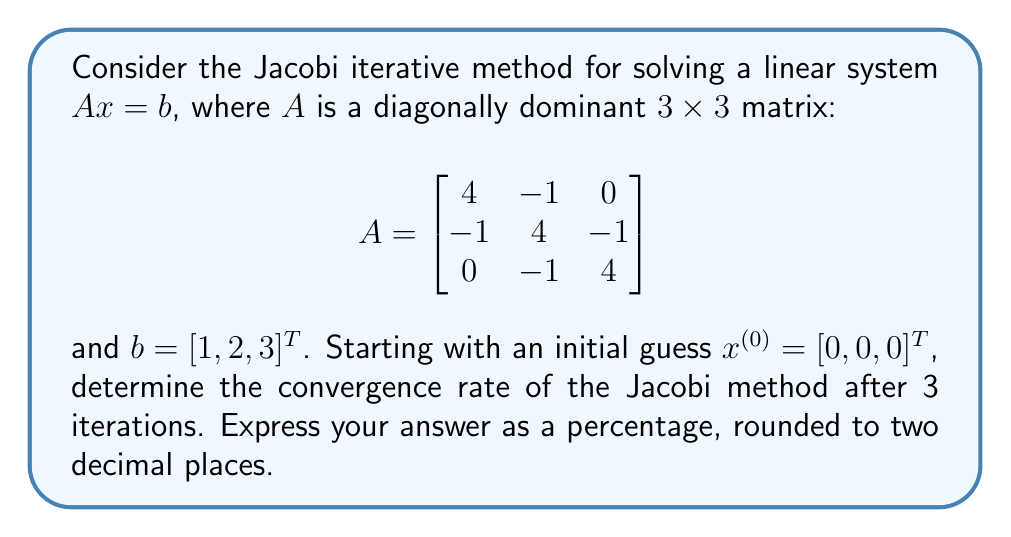Teach me how to tackle this problem. To analyze the convergence rate of the Jacobi method, we'll follow these steps:

1) First, we need to understand the Jacobi iteration formula:
   $x^{(k+1)} = D^{-1}(b - Rx^{(k)})$
   where $D$ is the diagonal of $A$, and $R = A - D$.

2) For our matrix $A$:
   $D = \begin{bmatrix}
   4 & 0 & 0 \\
   0 & 4 & 0 \\
   0 & 0 & 4
   \end{bmatrix}$
   
   $R = \begin{bmatrix}
   0 & -1 & 0 \\
   -1 & 0 & -1 \\
   0 & -1 & 0
   \end{bmatrix}$

3) The iteration formula becomes:
   $x_i^{(k+1)} = \frac{1}{4}(b_i - \sum_{j \neq i} a_{ij}x_j^{(k)})$

4) Let's perform 3 iterations:

   Iteration 1:
   $x_1^{(1)} = \frac{1}{4}(1 - 0) = 0.25$
   $x_2^{(1)} = \frac{1}{4}(2 - 0) = 0.5$
   $x_3^{(1)} = \frac{1}{4}(3 - 0) = 0.75$

   Iteration 2:
   $x_1^{(2)} = \frac{1}{4}(1 - (-0.5)) = 0.375$
   $x_2^{(2)} = \frac{1}{4}(2 - (-0.25 - 0.75)) = 0.75$
   $x_3^{(2)} = \frac{1}{4}(3 - (-0.5)) = 0.875$

   Iteration 3:
   $x_1^{(3)} = \frac{1}{4}(1 - (-0.75)) = 0.4375$
   $x_2^{(3)} = \frac{1}{4}(2 - (-0.375 - 0.875)) = 0.8125$
   $x_3^{(3)} = \frac{1}{4}(3 - (-0.75)) = 0.9375$

5) To calculate the convergence rate, we'll use the formula:
   Convergence Rate = $\left(1 - \frac{\|x^{(k)} - x^{(k-1)}\|}{\|x^{(k-1)} - x^{(k-2)}\|}\right) \times 100\%$

   where $\|\cdot\|$ denotes the Euclidean norm.

6) Calculate the norms:
   $\|x^{(3)} - x^{(2)}\| = \sqrt{(0.4375-0.375)^2 + (0.8125-0.75)^2 + (0.9375-0.875)^2} \approx 0.1083$
   $\|x^{(2)} - x^{(1)}\| = \sqrt{(0.375-0.25)^2 + (0.75-0.5)^2 + (0.875-0.75)^2} \approx 0.3307$

7) Apply the convergence rate formula:
   Convergence Rate = $\left(1 - \frac{0.1083}{0.3307}\right) \times 100\% \approx 67.25\%$

Therefore, the convergence rate after 3 iterations is approximately 67.25%.
Answer: 67.25% 